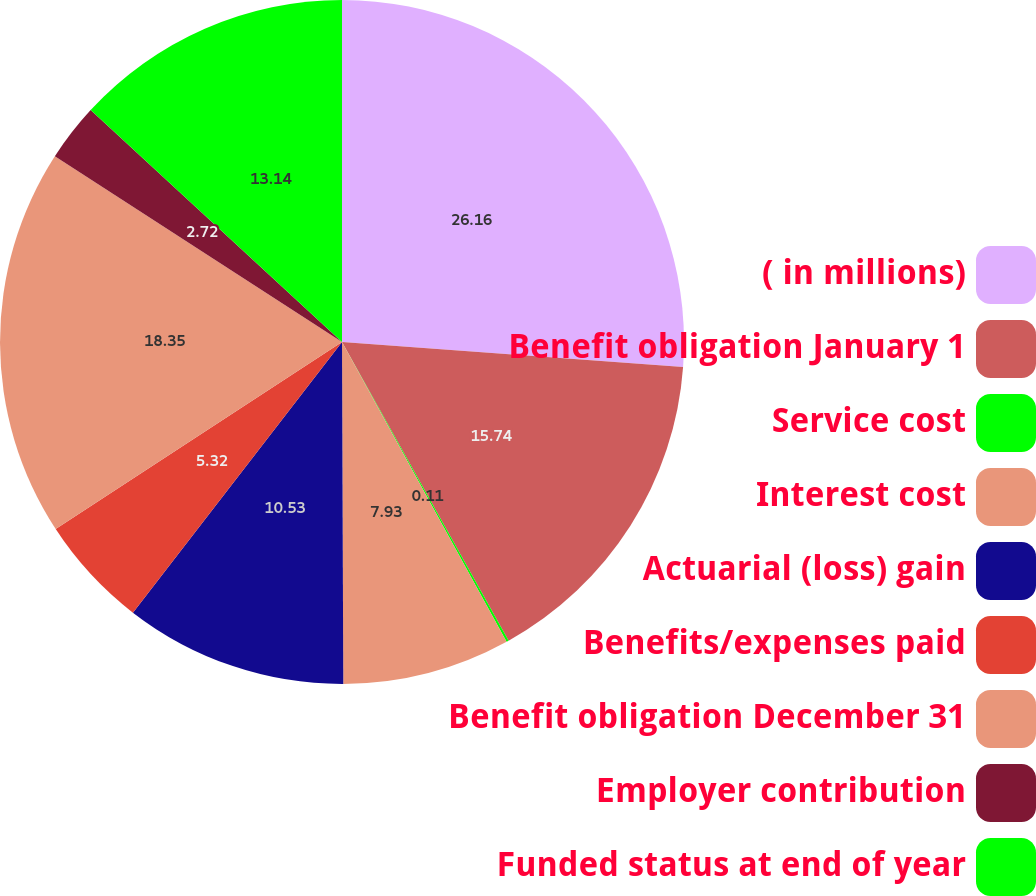Convert chart. <chart><loc_0><loc_0><loc_500><loc_500><pie_chart><fcel>( in millions)<fcel>Benefit obligation January 1<fcel>Service cost<fcel>Interest cost<fcel>Actuarial (loss) gain<fcel>Benefits/expenses paid<fcel>Benefit obligation December 31<fcel>Employer contribution<fcel>Funded status at end of year<nl><fcel>26.16%<fcel>15.74%<fcel>0.11%<fcel>7.93%<fcel>10.53%<fcel>5.32%<fcel>18.35%<fcel>2.72%<fcel>13.14%<nl></chart> 